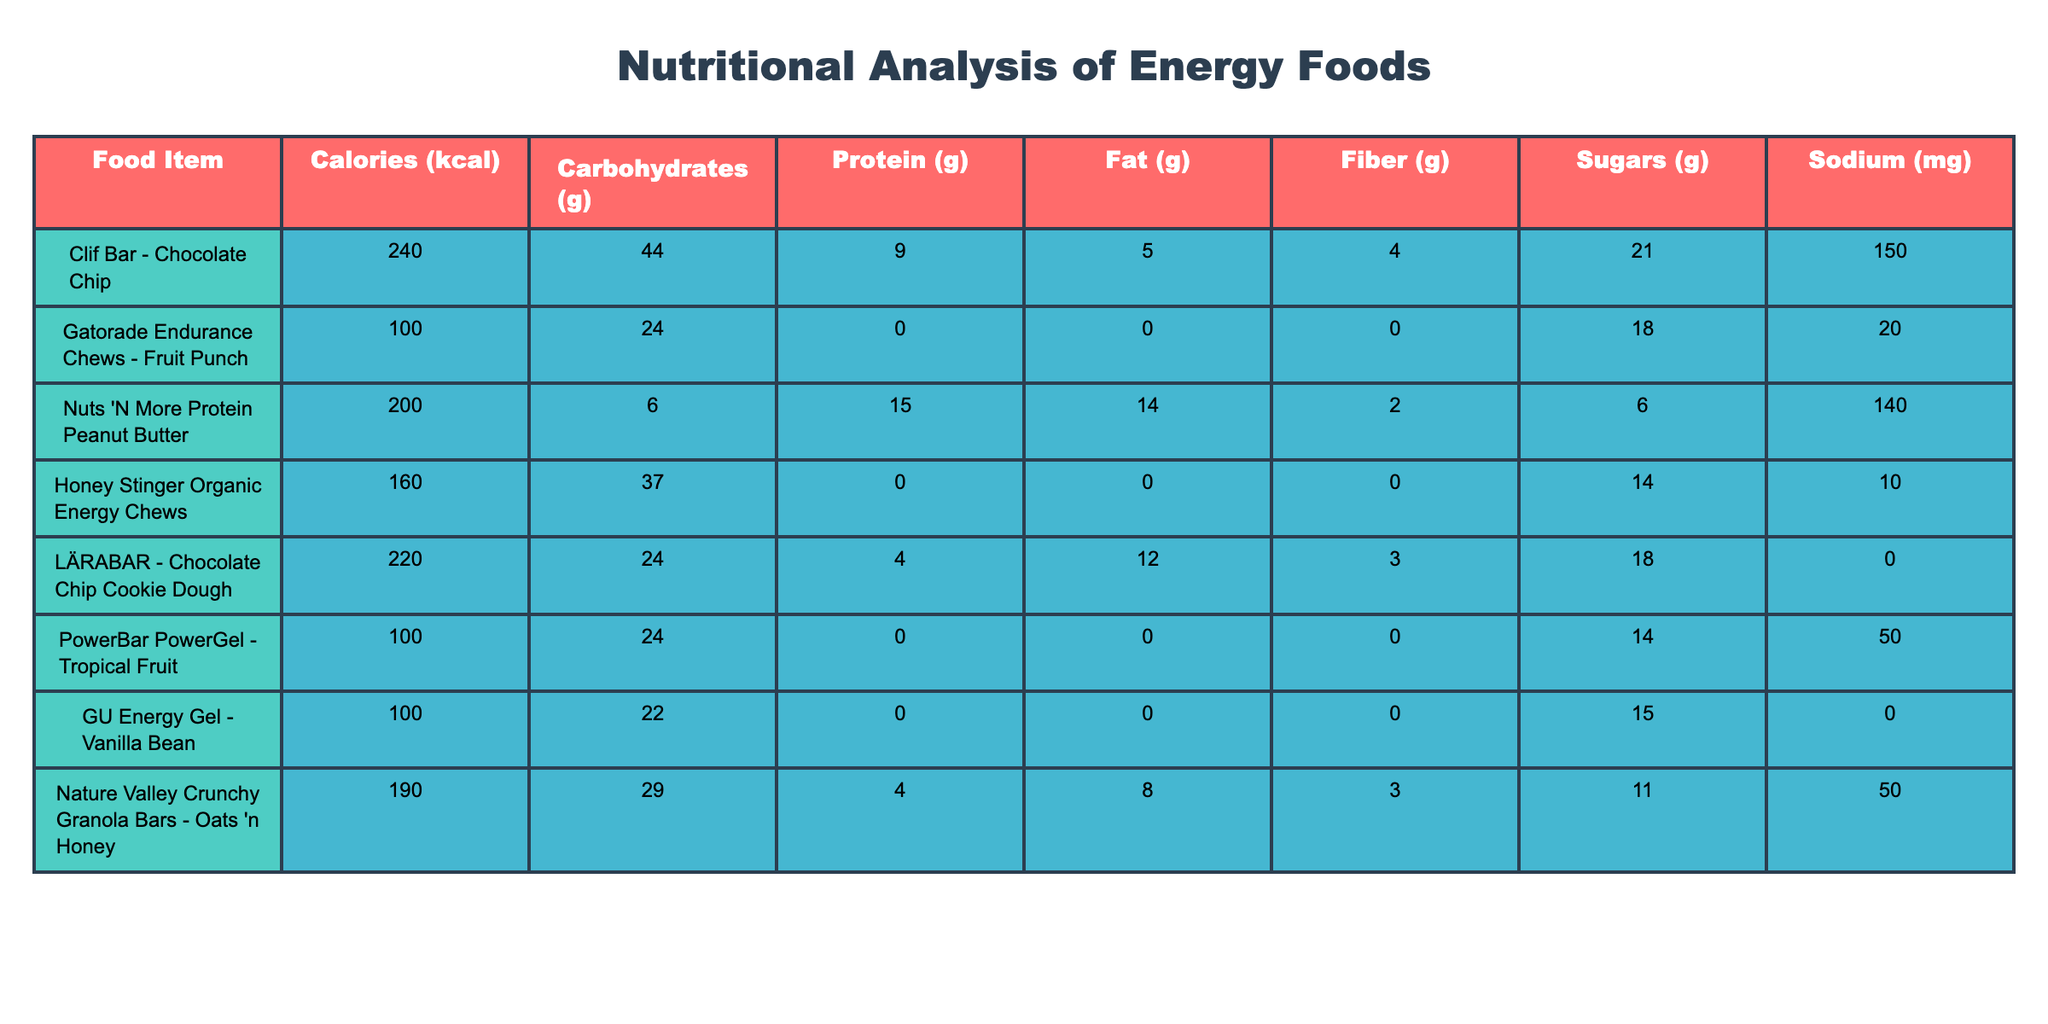What is the highest calorie food item listed in the table? The table shows various food items with their calorie content listed. By looking through the "Calories" column, the item "Clif Bar - Chocolate Chip" has the highest value of 240 kcal.
Answer: 240 Which food item has the most protein? To find the item with the most protein, we look at the "Protein (g)" column and identify the maximum value. "Nuts 'N More Protein Peanut Butter" has the highest protein content at 15 grams.
Answer: Nuts 'N More Protein Peanut Butter How many grams of carbohydrates are in the Honey Stinger Organic Energy Chews? The "Carbohydrates (g)" column shows the value for Honey Stinger Organic Energy Chews is 37 grams.
Answer: 37 What is the average amount of sugar in the food items listed? To find the average sugar content, we sum the sugars from all items: (21 + 18 + 6 + 14 + 18 + 14 + 15 + 11) = 117 grams. There are 8 food items, so the average is 117/8 = 14.625 grams, rounding gives approximately 14.6 grams.
Answer: Approximately 14.6 grams Is there any food item with zero sodium? We can check the "Sodium (mg)" column for items with a value of zero. Two items, "LÄRABAR - Chocolate Chip Cookie Dough" and "GU Energy Gel - Vanilla Bean," have zero sodium content. Thus, the answer is yes.
Answer: Yes What is the total fat content in the top three items by calories? The top three calorie items by checking the "Calories" column are "Clif Bar - Chocolate Chip" (5 g), "LÄRABAR - Chocolate Chip Cookie Dough" (12 g), and "Nuts 'N More Protein Peanut Butter" (14 g). Adding these together gives us 5 + 12 + 14 = 31 grams.
Answer: 31 grams Which food item has the lowest amount of calories? Reviewing the "Calories" column, "Gatorade Endurance Chews - Fruit Punch" has the lowest calorie count at 100 kcal.
Answer: 100 Does any item have more carbohydrates than the Clif Bar - Chocolate Chip? The Clif Bar contains 44 grams of carbohydrates. By checking other items, "Honey Stinger Organic Energy Chews" has 37 grams and all others have less. Therefore, none of the items exceed 44 grams.
Answer: No If you combine the fiber contents of the top two with the most fiber, what would be the result? The two food items with the most fiber are "Clif Bar - Chocolate Chip" (4 g) and "Honey Stinger Organic Energy Chews" (0 g). Their combined fiber content is 4 + 0 = 4 grams.
Answer: 4 grams 